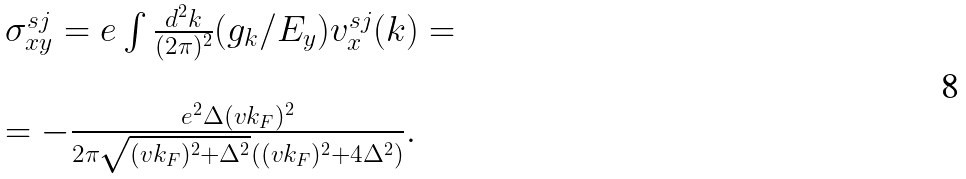<formula> <loc_0><loc_0><loc_500><loc_500>\begin{array} { l } \sigma _ { x y } ^ { s j } = e \int \frac { d ^ { 2 } { k } } { ( 2 \pi ) ^ { 2 } } ( g _ { k } / E _ { y } ) v _ { x } ^ { s j } ( { k } ) = \\ \\ = - \frac { e ^ { 2 } \Delta ( v k _ { F } ) ^ { 2 } } { 2 \pi \sqrt { ( v k _ { F } ) ^ { 2 } + \Delta ^ { 2 } } ( ( v k _ { F } ) ^ { 2 } + 4 \Delta ^ { 2 } ) } . \end{array}</formula> 